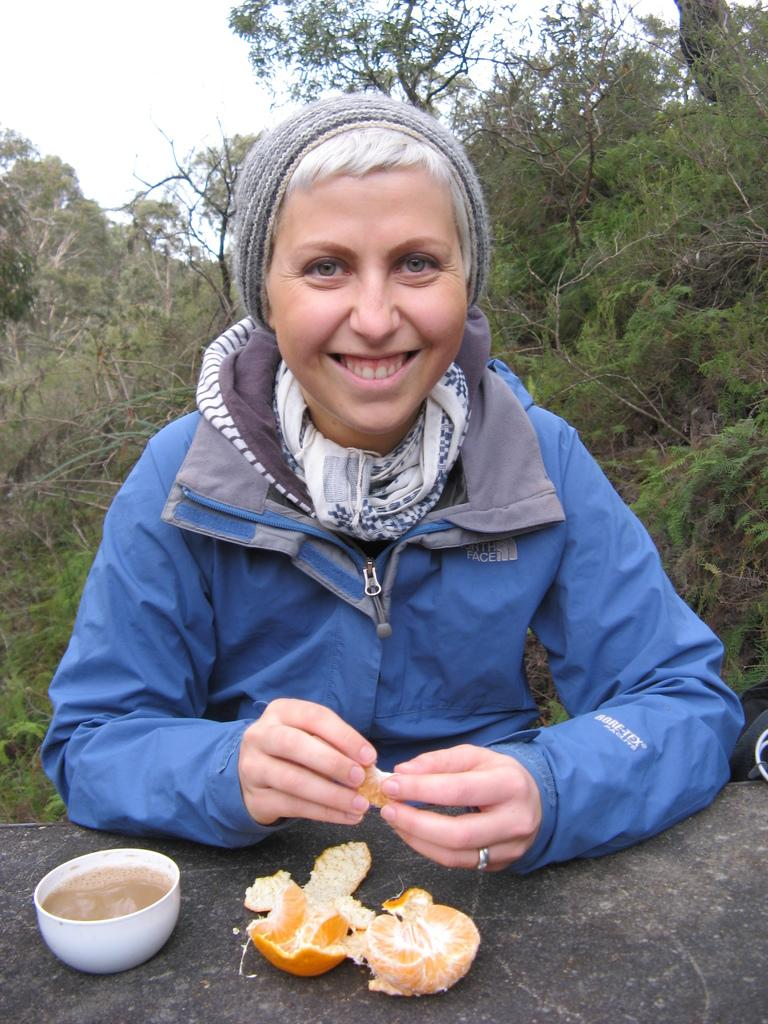Who is present in the image? There is a woman in the image. What is the woman wearing? The woman is wearing a jacket and a cap. What is the woman's facial expression? The woman is smiling. What is placed on the rock in the image? There is a cup with a drink and an orange in the image. What can be seen in the background of the image? There are trees and the sky visible in the background of the image. What is the woman's annual income in the image? There is no information about the woman's income in the image. How does the goose interact with the woman in the image? There is no goose present in the image. 